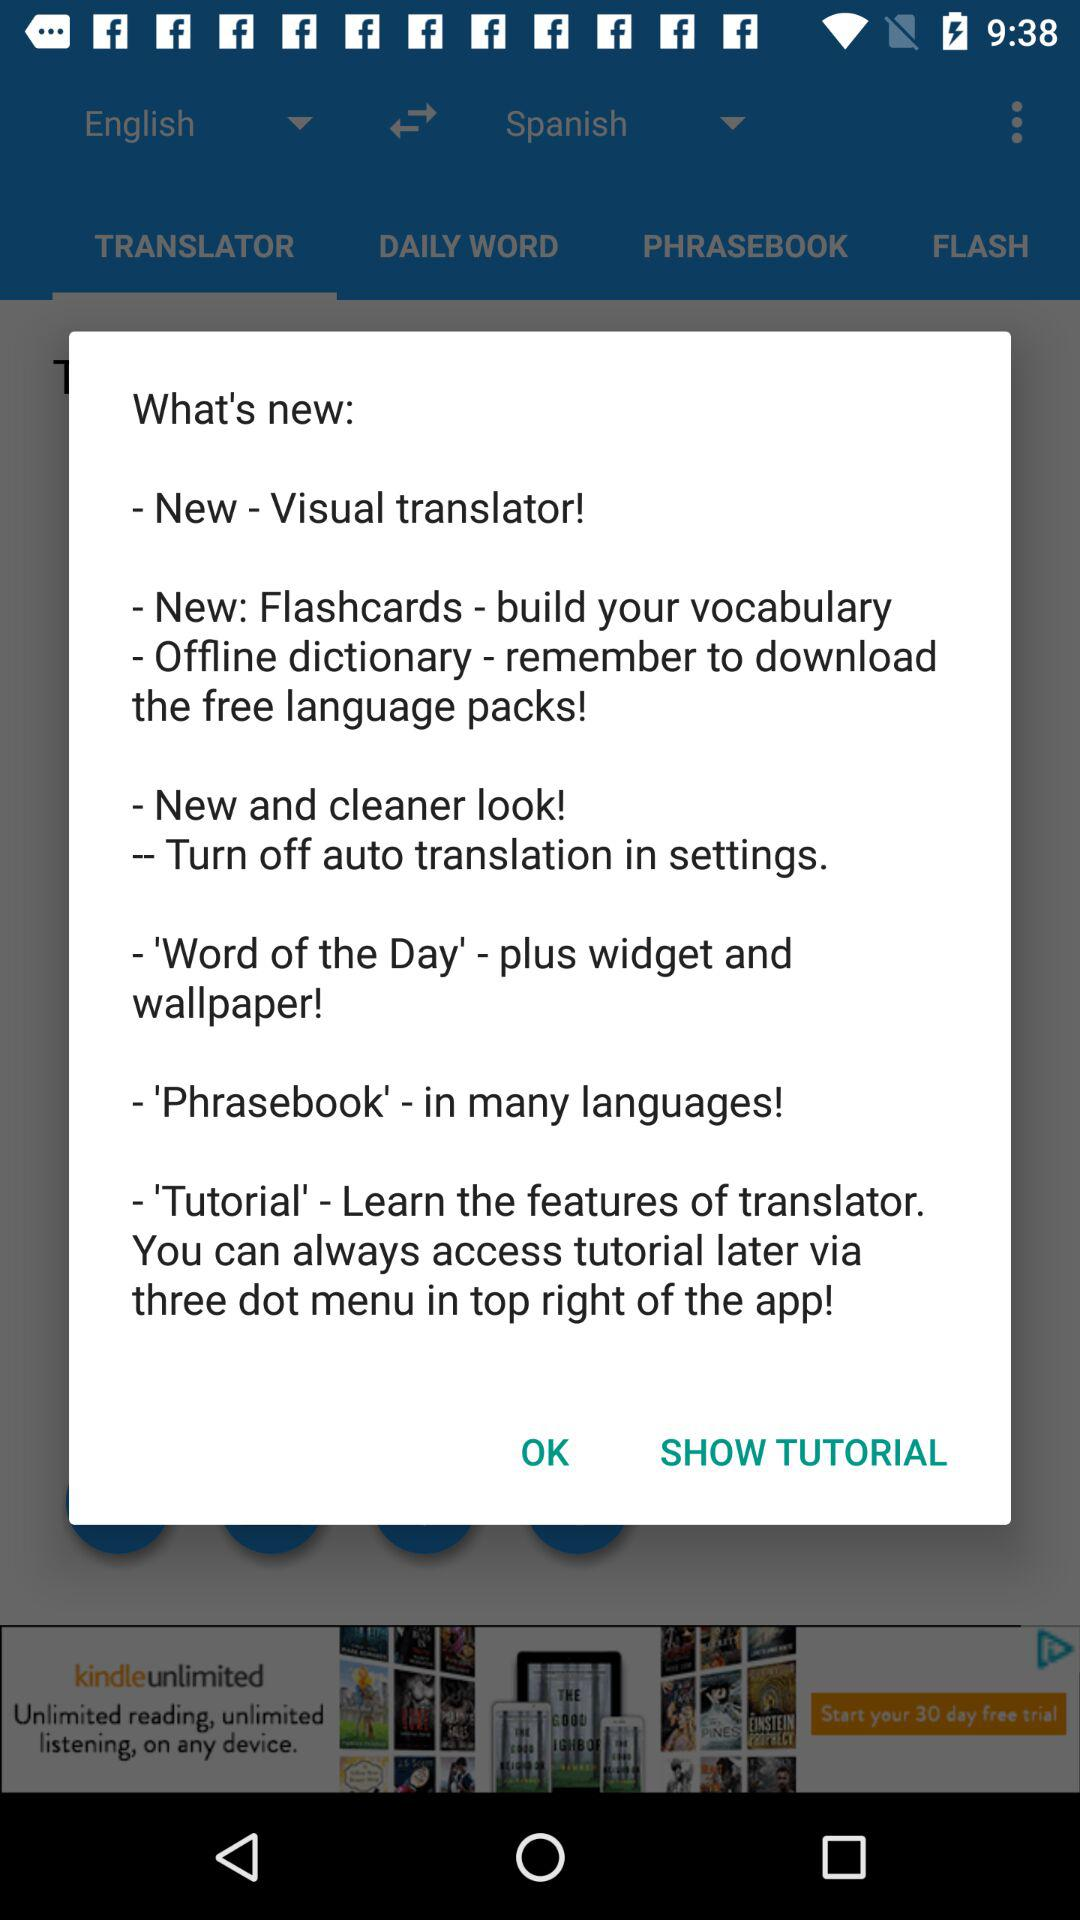What are the new features available? The new features available are "New - Visual translator!", "New: Flashcards - build your vocabulary", "Offline dictionary - remember to download the free language packs!", "New and cleaner look! : Turn off auto translation in settings.", "'Word of the Day' - plus widget and wallpaper!", "'Phrasebook' - in many languages!" and "'Tutorial' - Learn the features of translator". 